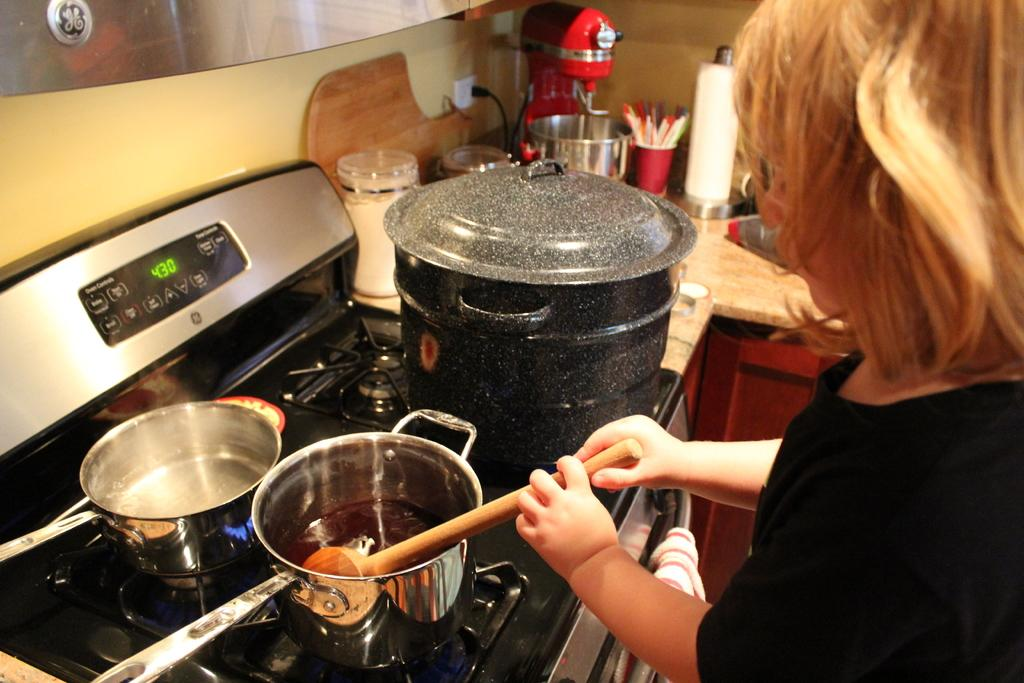<image>
Create a compact narrative representing the image presented. a person cooking over a stove with the time showing 4:30 